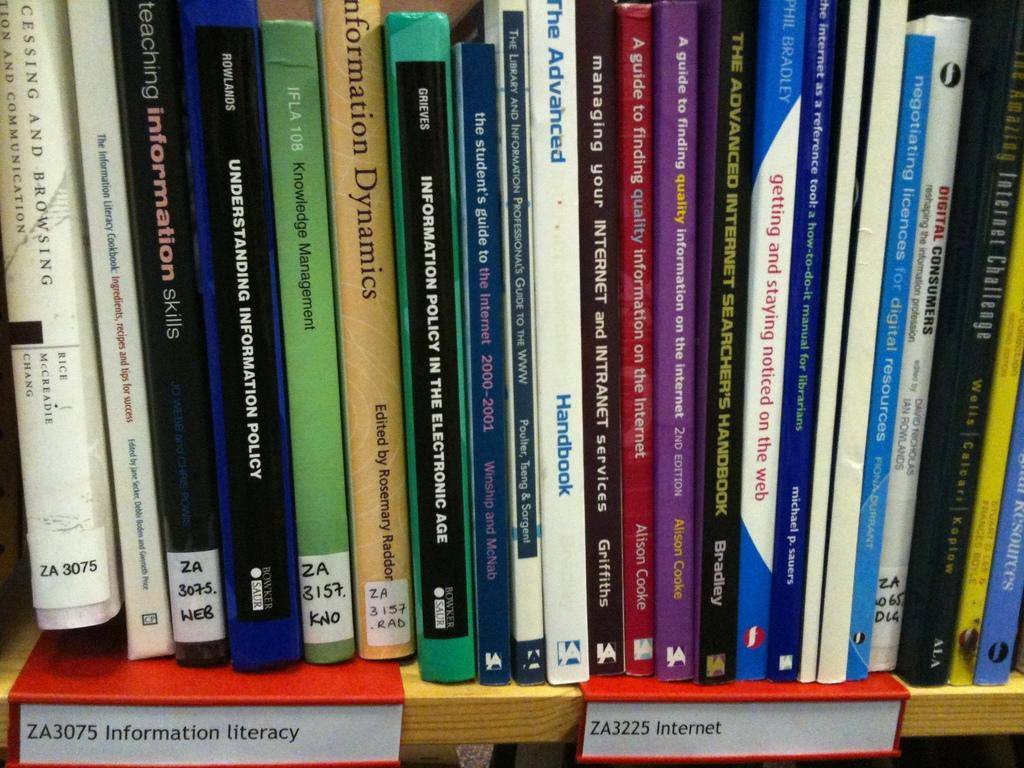<image>
Summarize the visual content of the image. A filled up bookshelf, below the shelf are labels that say Information Literacy. 